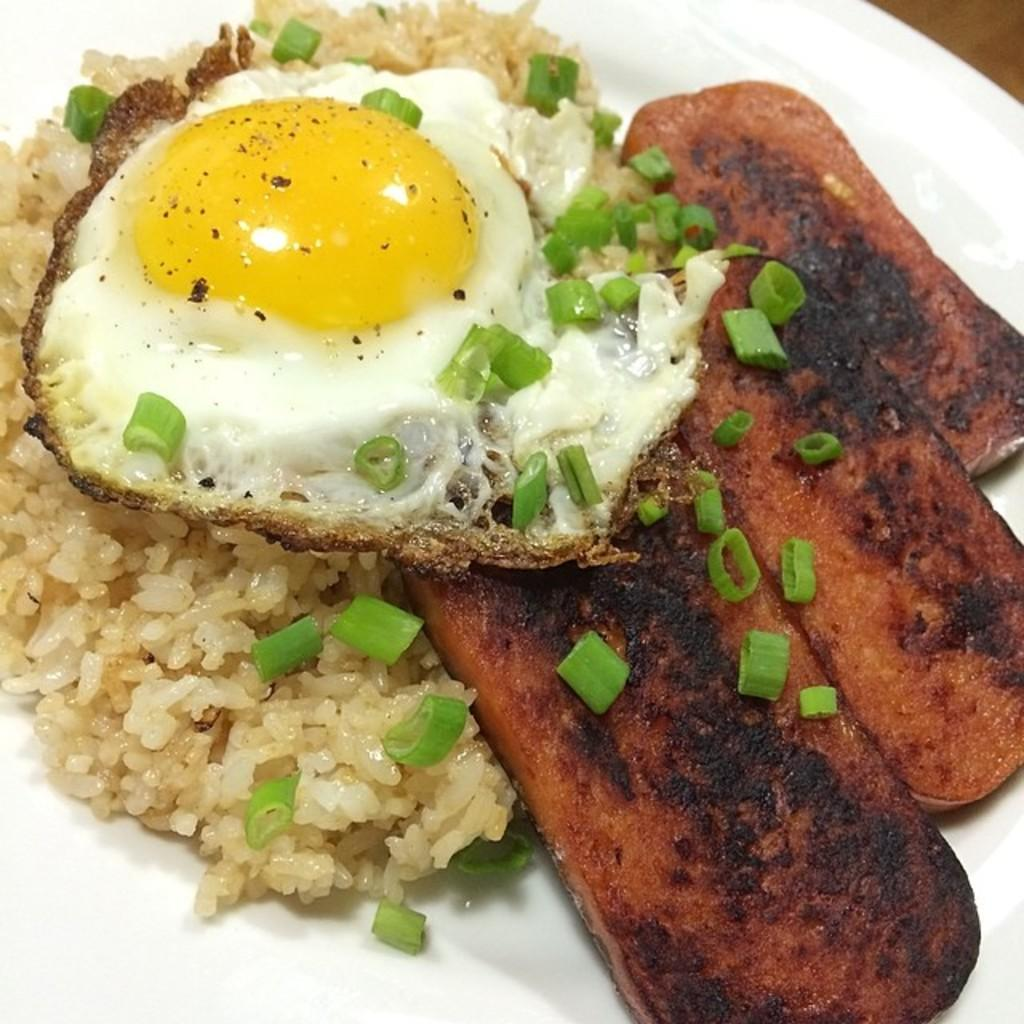What is on the table in the image? There is a plate on the table in the image. What is on the plate? There is rice, an omelette, and meat on the plate. How many different types of food are on the plate? There are three different types of food on the plate: rice, an omelette, and meat. What type of deer can be seen walking around the table in the image? There are no deer present in the image; it only shows a plate with food on a table. 